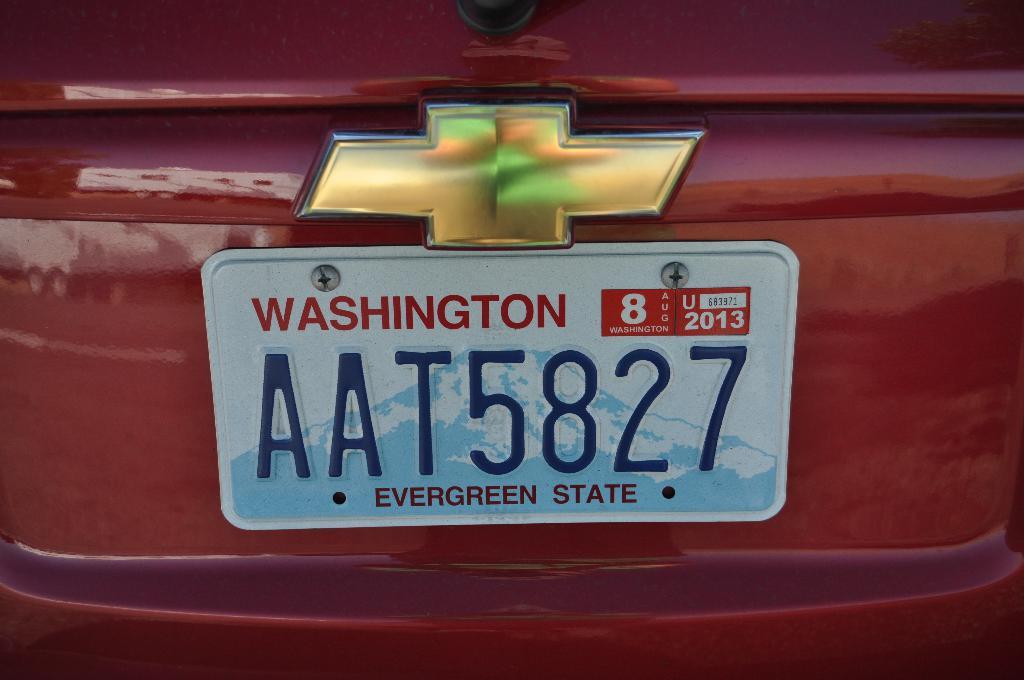What state is this license plate from?
Provide a short and direct response. Washington. What is washington state known to be?
Your answer should be compact. Evergreen state. 